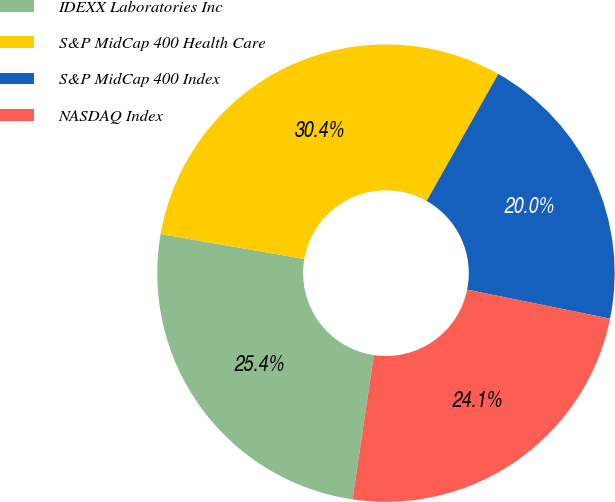Convert chart. <chart><loc_0><loc_0><loc_500><loc_500><pie_chart><fcel>IDEXX Laboratories Inc<fcel>S&P MidCap 400 Health Care<fcel>S&P MidCap 400 Index<fcel>NASDAQ Index<nl><fcel>25.4%<fcel>30.44%<fcel>20.02%<fcel>24.15%<nl></chart> 